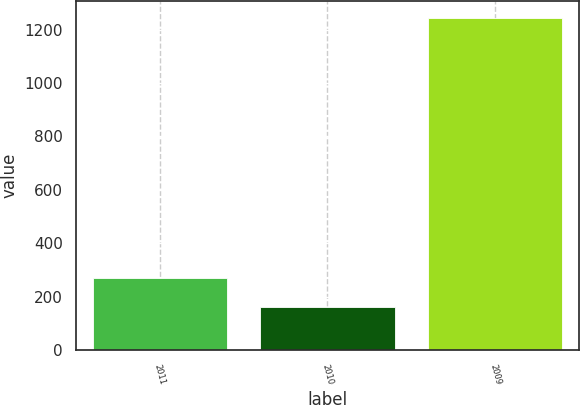Convert chart to OTSL. <chart><loc_0><loc_0><loc_500><loc_500><bar_chart><fcel>2011<fcel>2010<fcel>2009<nl><fcel>270.3<fcel>162<fcel>1245<nl></chart> 